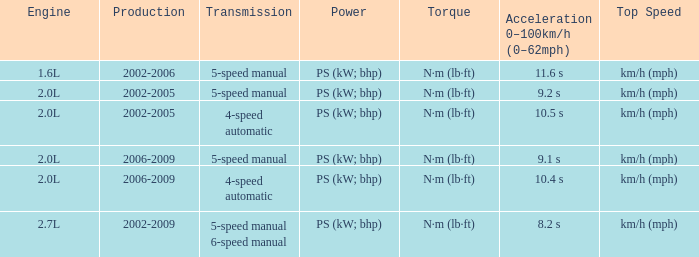What is the peak speed of a 4-speed automatic made during 2002-2005? Km/h (mph). 